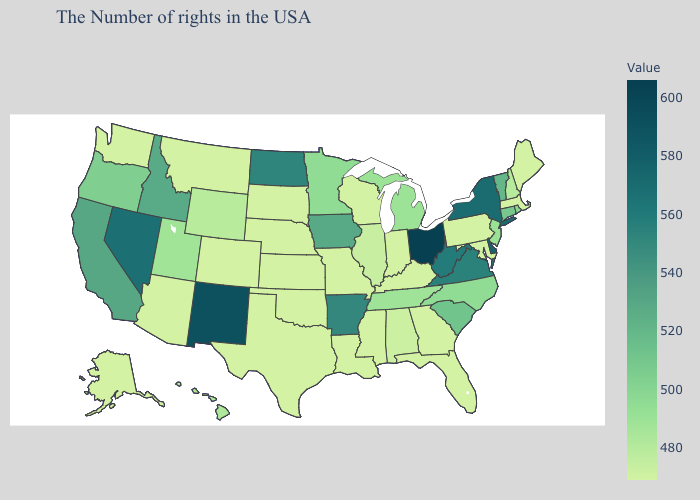Does Pennsylvania have the highest value in the Northeast?
Answer briefly. No. Among the states that border Illinois , which have the lowest value?
Quick response, please. Kentucky, Indiana, Wisconsin, Missouri. Does Indiana have a lower value than Utah?
Give a very brief answer. Yes. Among the states that border Indiana , which have the highest value?
Give a very brief answer. Ohio. Does Montana have the lowest value in the West?
Keep it brief. Yes. Does Rhode Island have a lower value than Texas?
Quick response, please. No. 